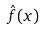Convert formula to latex. <formula><loc_0><loc_0><loc_500><loc_500>\hat { f } ( x )</formula> 